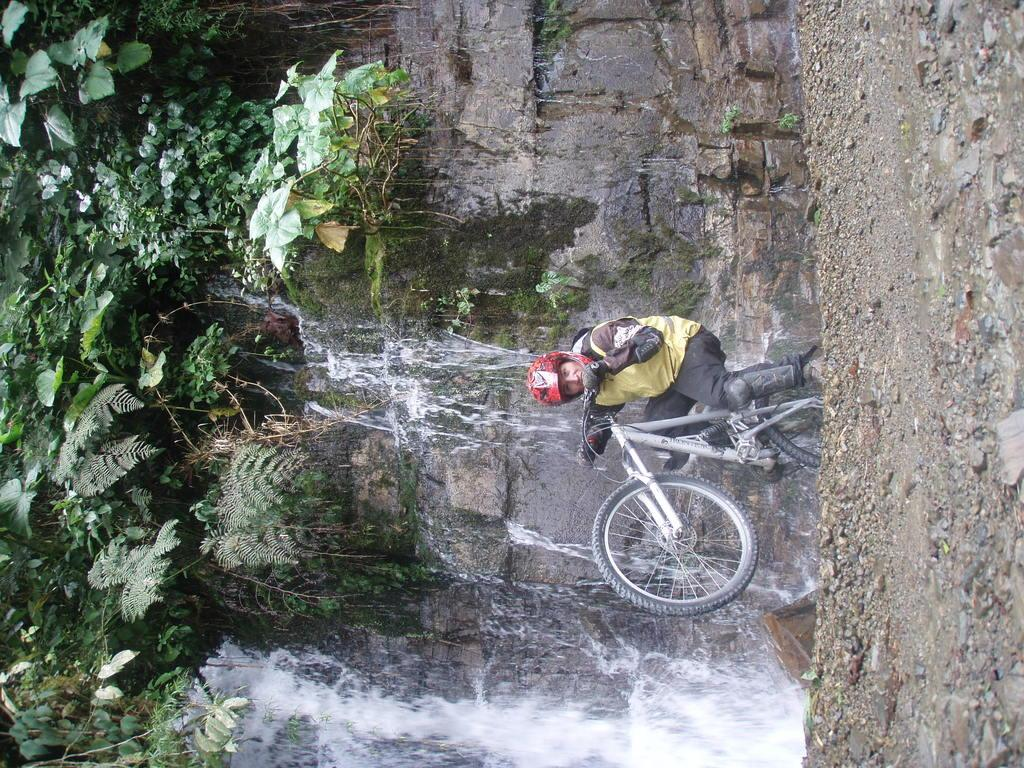What is the main subject of the image? There is a person in the image. What is the person doing in the image? The person is holding a bicycle on the ground. What safety precaution is the person taking? The person is wearing a helmet. What can be seen in the background of the image? There is water, a wall, and trees visible in the background of the image. How many houses are visible in the image? There are no houses visible in the image; it features a person holding a bicycle with a background of water, a wall, and trees. 